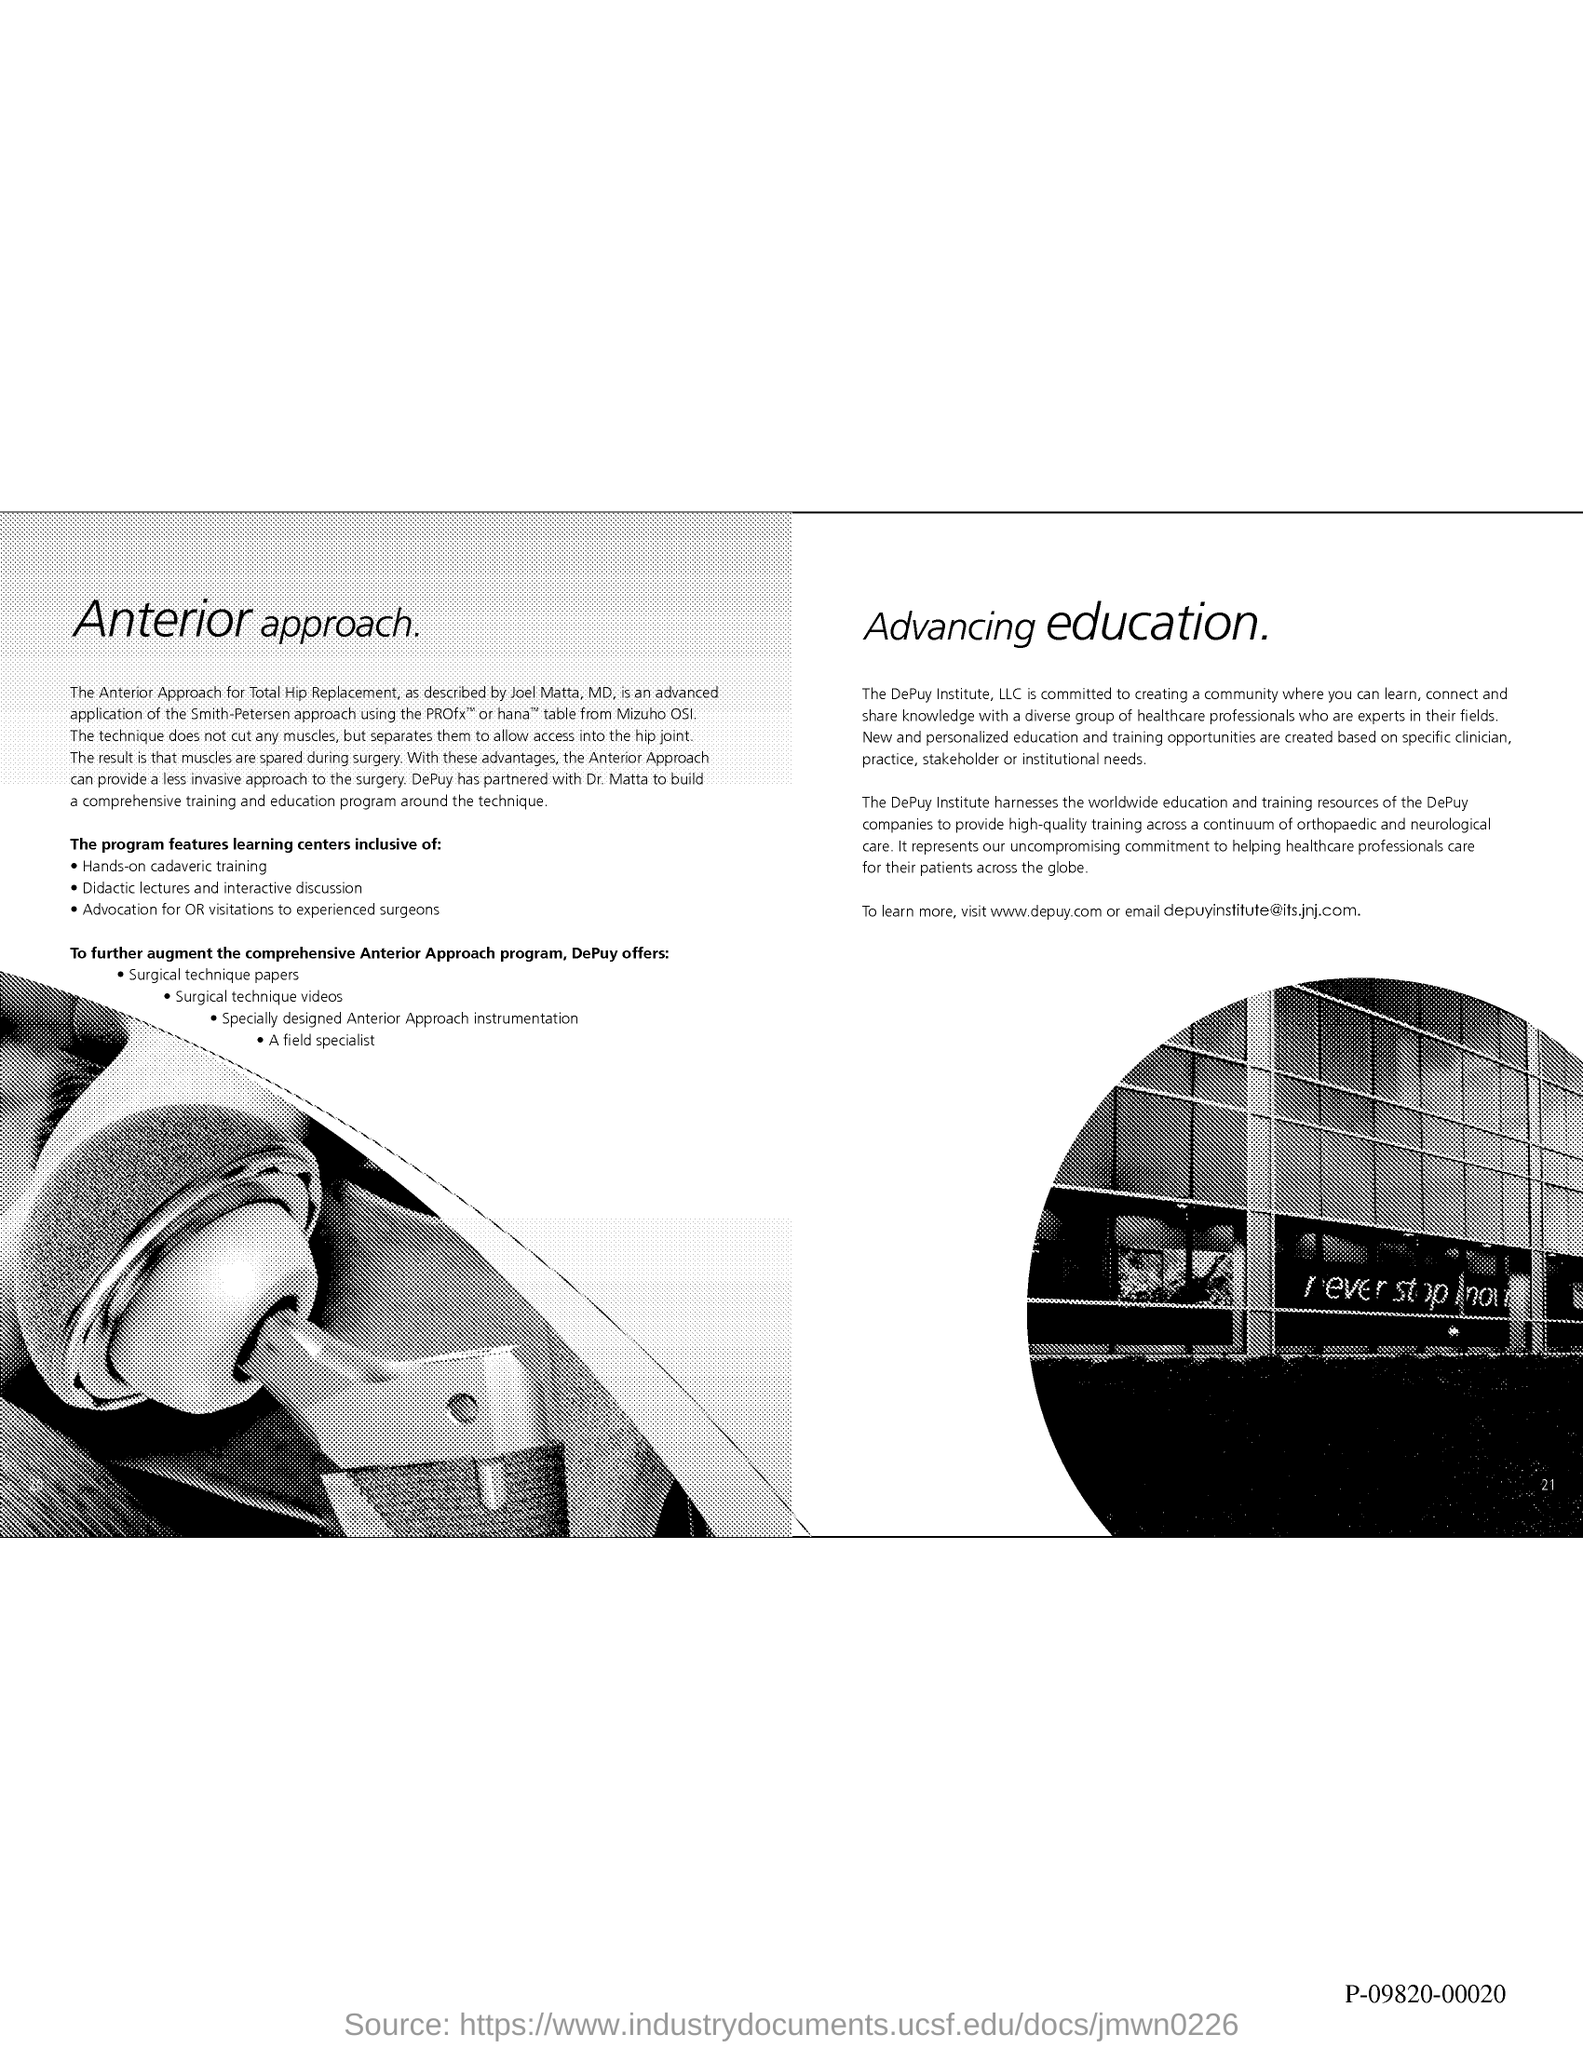Draw attention to some important aspects in this diagram. To learn more about DePuy, please visit the website [www.depuy.com](http://www.depuy.com). The email address is "[depuyinstitute@its.jnj.com](mailto:depuyinstitute@its.jnj.com)". 